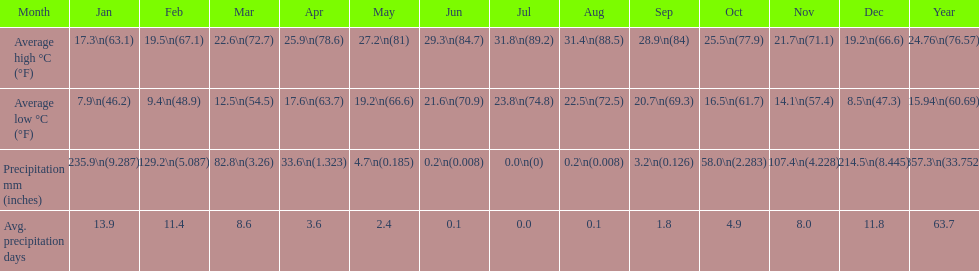Which month held the most precipitation? January. 